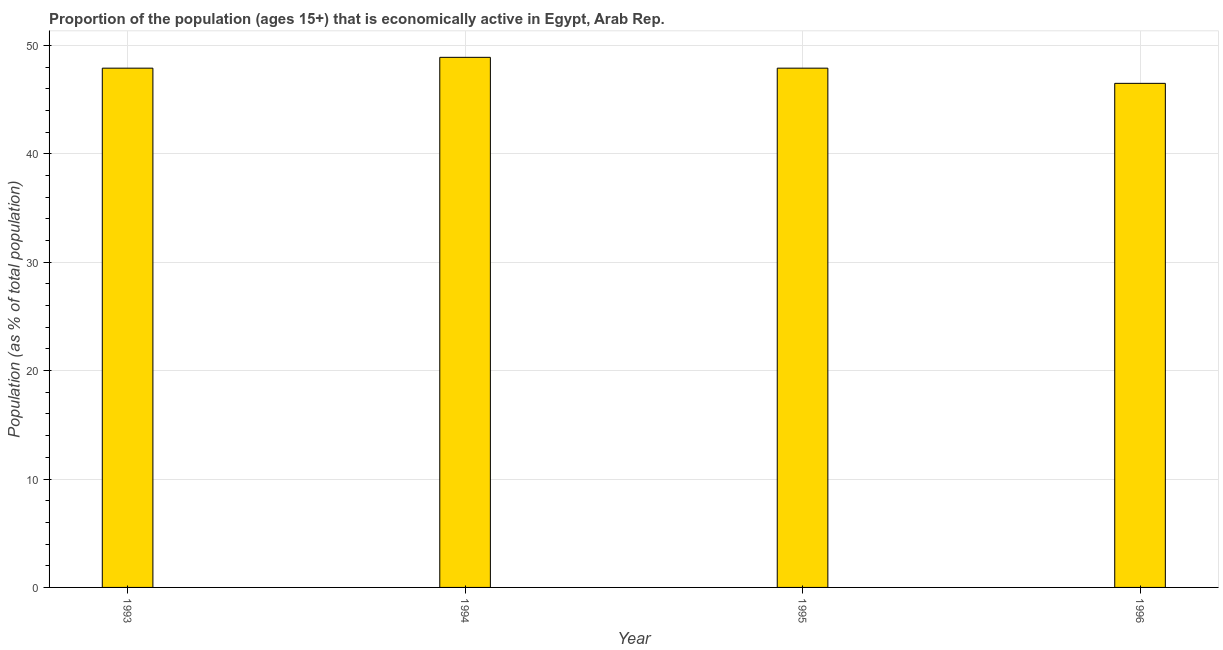Does the graph contain any zero values?
Your answer should be compact. No. What is the title of the graph?
Offer a terse response. Proportion of the population (ages 15+) that is economically active in Egypt, Arab Rep. What is the label or title of the X-axis?
Offer a terse response. Year. What is the label or title of the Y-axis?
Your answer should be compact. Population (as % of total population). What is the percentage of economically active population in 1994?
Your answer should be very brief. 48.9. Across all years, what is the maximum percentage of economically active population?
Offer a terse response. 48.9. Across all years, what is the minimum percentage of economically active population?
Offer a terse response. 46.5. In which year was the percentage of economically active population maximum?
Your answer should be compact. 1994. What is the sum of the percentage of economically active population?
Make the answer very short. 191.2. What is the average percentage of economically active population per year?
Provide a short and direct response. 47.8. What is the median percentage of economically active population?
Your response must be concise. 47.9. Is the percentage of economically active population in 1994 less than that in 1996?
Keep it short and to the point. No. Is the difference between the percentage of economically active population in 1994 and 1996 greater than the difference between any two years?
Your response must be concise. Yes. Is the sum of the percentage of economically active population in 1994 and 1996 greater than the maximum percentage of economically active population across all years?
Your answer should be very brief. Yes. How many bars are there?
Offer a terse response. 4. Are all the bars in the graph horizontal?
Give a very brief answer. No. How many years are there in the graph?
Your response must be concise. 4. What is the difference between two consecutive major ticks on the Y-axis?
Make the answer very short. 10. Are the values on the major ticks of Y-axis written in scientific E-notation?
Give a very brief answer. No. What is the Population (as % of total population) in 1993?
Provide a short and direct response. 47.9. What is the Population (as % of total population) in 1994?
Give a very brief answer. 48.9. What is the Population (as % of total population) of 1995?
Offer a very short reply. 47.9. What is the Population (as % of total population) of 1996?
Ensure brevity in your answer.  46.5. What is the difference between the Population (as % of total population) in 1993 and 1996?
Your answer should be compact. 1.4. What is the difference between the Population (as % of total population) in 1995 and 1996?
Give a very brief answer. 1.4. What is the ratio of the Population (as % of total population) in 1993 to that in 1996?
Provide a succinct answer. 1.03. What is the ratio of the Population (as % of total population) in 1994 to that in 1995?
Keep it short and to the point. 1.02. What is the ratio of the Population (as % of total population) in 1994 to that in 1996?
Your response must be concise. 1.05. 